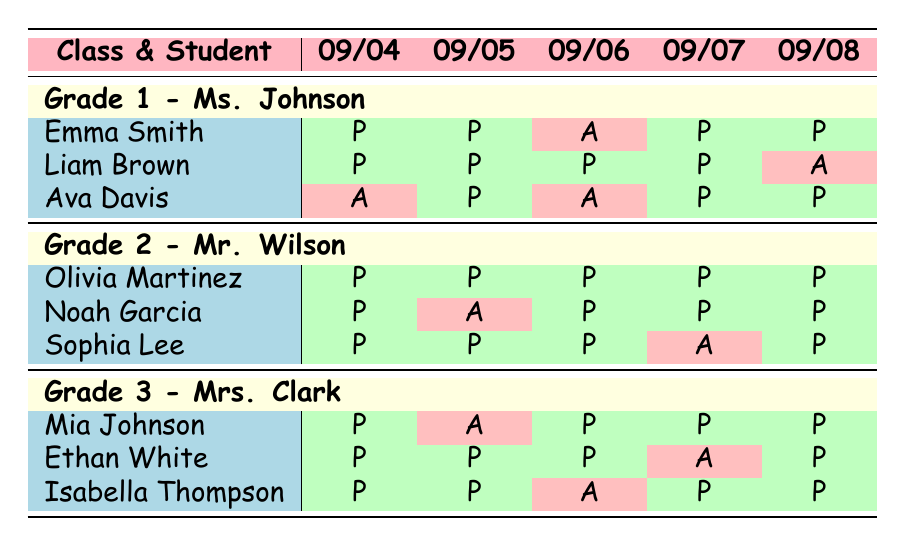What is Ava Davis's attendance status on September 4th? According to the attendance record, Ava Davis's status on September 4th is "Absent" as indicated by a red cell in the table.
Answer: Absent How many days did Liam Brown attend class? Liam Brown was present on September 4th, 5th, 6th, and 7th, but absent on September 8th, which makes it a total of 4 days attended.
Answer: 4 days Did Olivia Martinez miss any days of school? Olivia Martinez is marked as "Present" for all dates, so she did not miss any days of school.
Answer: No Which student had the highest number of attendance in Grade 1? To determine this, we check attendance records. Emma Smith attended 4 days, Liam Brown attended 4 days, and Ava Davis attended 3 days. Emma and Liam tied for the highest attendance with 4 days.
Answer: Emma Smith and Liam Brown What is the total number of absences for Grade 3 students? Mia Johnson had 1 absence, Ethan White had 1 absence, and Isabella Thompson had 1 absence, totaling 3 absences across all Grade 3 students.
Answer: 3 absences How many students in Grade 2 were present on September 6th? All students in Grade 2 - Mr. Wilson, namely Olivia Martinez, Noah Garcia, and Sophia Lee, were present on September 6th, resulting in a total of 3 students present.
Answer: 3 students On which date did Noah Garcia have an absence? Noah Garcia was absent on September 5th, as indicated by the red cell under that date in the table.
Answer: September 5th Which grade had the highest number of students present on September 8th? Checking the attendance for September 8th, all Grade 2 and Grade 3 students were present, while only 2 out of 3 Grade 1 students were present. Thus, both Grade 2 and Grade 3 had 3 students present.
Answer: Grade 2 and Grade 3 What percentage of days did Mia Johnson attend class? Mia Johnson attended 4 out of 5 class days. To find the percentage, (4/5) * 100 = 80%.
Answer: 80% Which class had the most students on a specific absence date? On September 5th, Ava Davis from Grade 1 and Noah Garcia from Grade 2 were absent, and in Grade 3, all students were present. This means Grade 1 and Grade 2 tied for the most absences on that date with 1 each.
Answer: Grade 1 and Grade 2 (1 absence each) 